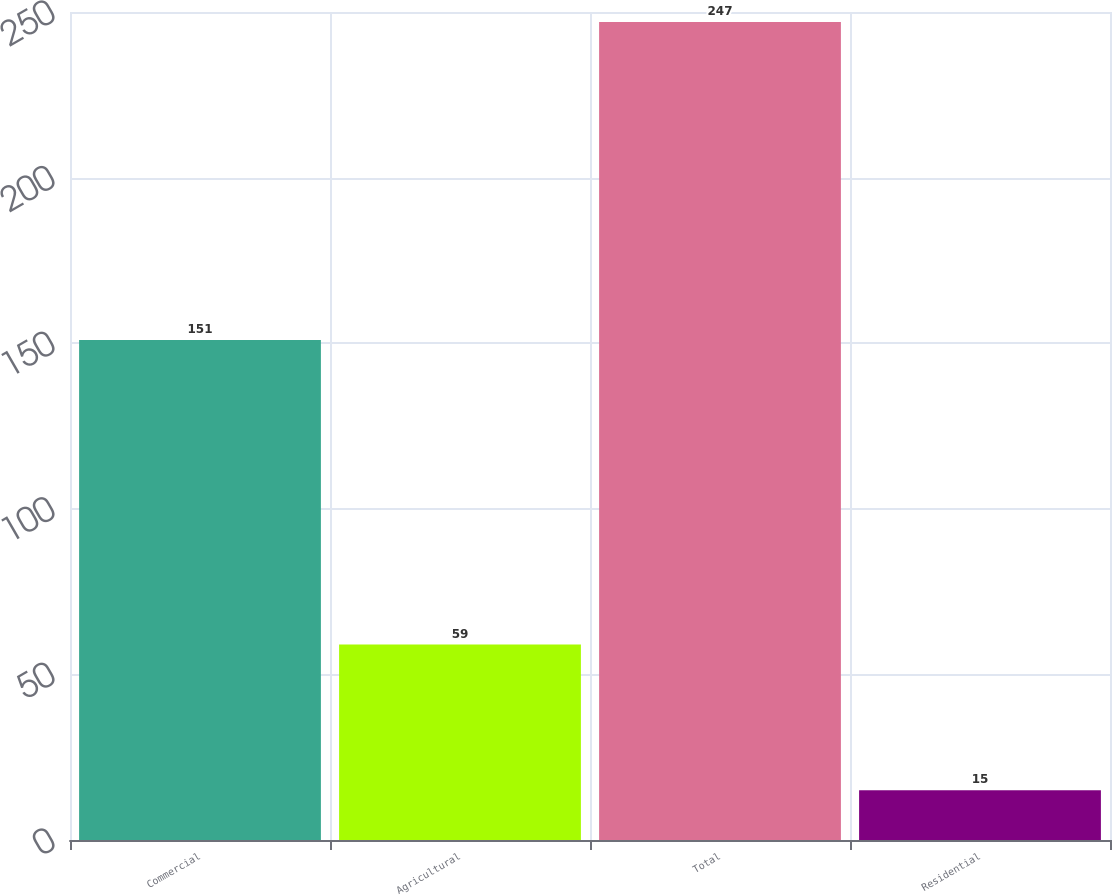Convert chart. <chart><loc_0><loc_0><loc_500><loc_500><bar_chart><fcel>Commercial<fcel>Agricultural<fcel>Total<fcel>Residential<nl><fcel>151<fcel>59<fcel>247<fcel>15<nl></chart> 